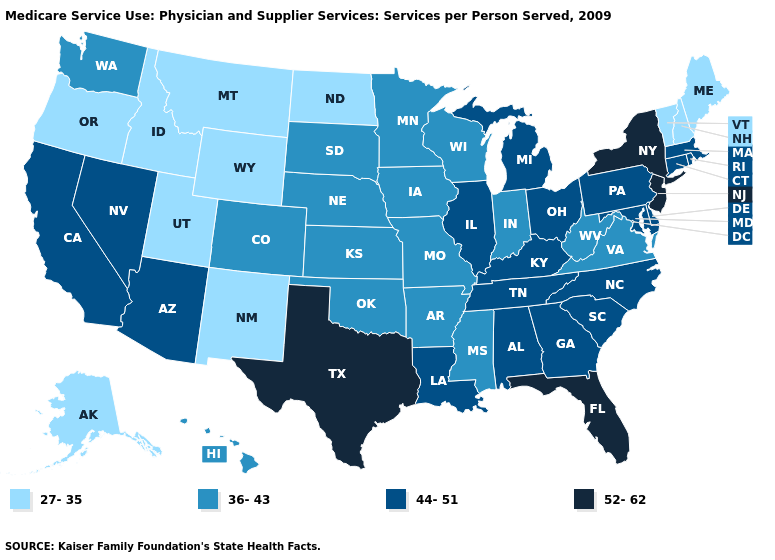Which states hav the highest value in the Northeast?
Write a very short answer. New Jersey, New York. What is the value of Wisconsin?
Write a very short answer. 36-43. What is the lowest value in states that border South Carolina?
Answer briefly. 44-51. What is the lowest value in states that border Pennsylvania?
Be succinct. 36-43. What is the value of North Carolina?
Quick response, please. 44-51. Does the map have missing data?
Short answer required. No. Name the states that have a value in the range 44-51?
Be succinct. Alabama, Arizona, California, Connecticut, Delaware, Georgia, Illinois, Kentucky, Louisiana, Maryland, Massachusetts, Michigan, Nevada, North Carolina, Ohio, Pennsylvania, Rhode Island, South Carolina, Tennessee. Does Michigan have the same value as Arkansas?
Give a very brief answer. No. Does Massachusetts have the same value as Oregon?
Be succinct. No. What is the value of North Carolina?
Write a very short answer. 44-51. Does New Jersey have the lowest value in the Northeast?
Short answer required. No. What is the value of North Dakota?
Keep it brief. 27-35. Name the states that have a value in the range 36-43?
Write a very short answer. Arkansas, Colorado, Hawaii, Indiana, Iowa, Kansas, Minnesota, Mississippi, Missouri, Nebraska, Oklahoma, South Dakota, Virginia, Washington, West Virginia, Wisconsin. Name the states that have a value in the range 44-51?
Concise answer only. Alabama, Arizona, California, Connecticut, Delaware, Georgia, Illinois, Kentucky, Louisiana, Maryland, Massachusetts, Michigan, Nevada, North Carolina, Ohio, Pennsylvania, Rhode Island, South Carolina, Tennessee. Does the map have missing data?
Short answer required. No. 